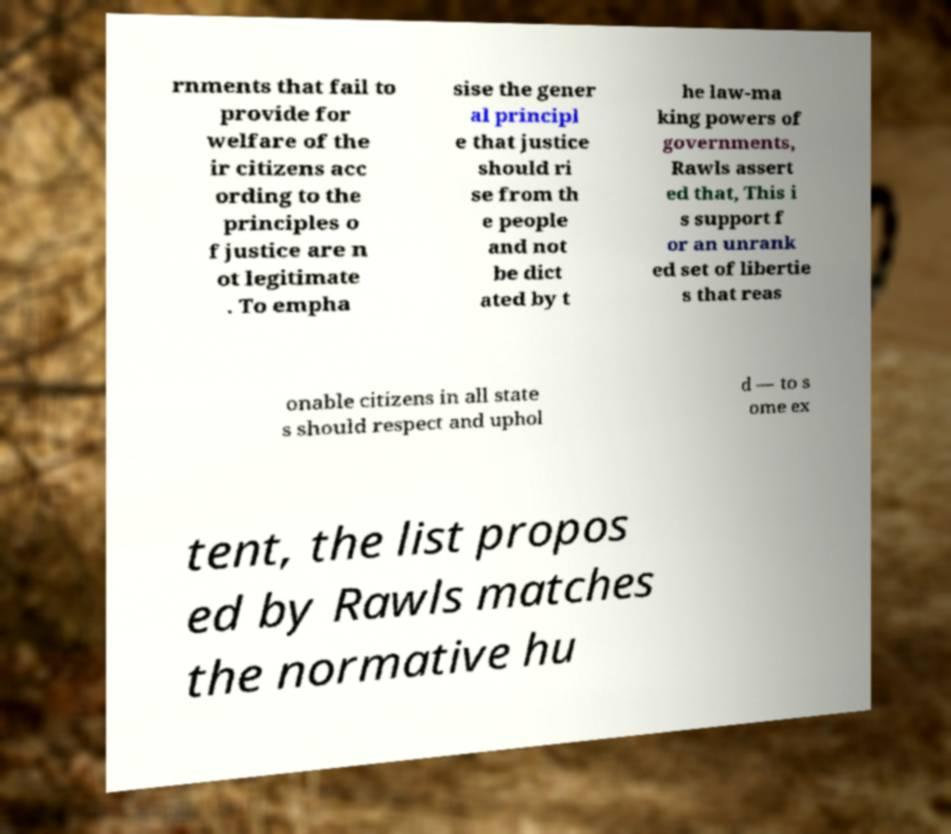Could you assist in decoding the text presented in this image and type it out clearly? rnments that fail to provide for welfare of the ir citizens acc ording to the principles o f justice are n ot legitimate . To empha sise the gener al principl e that justice should ri se from th e people and not be dict ated by t he law-ma king powers of governments, Rawls assert ed that, This i s support f or an unrank ed set of libertie s that reas onable citizens in all state s should respect and uphol d — to s ome ex tent, the list propos ed by Rawls matches the normative hu 